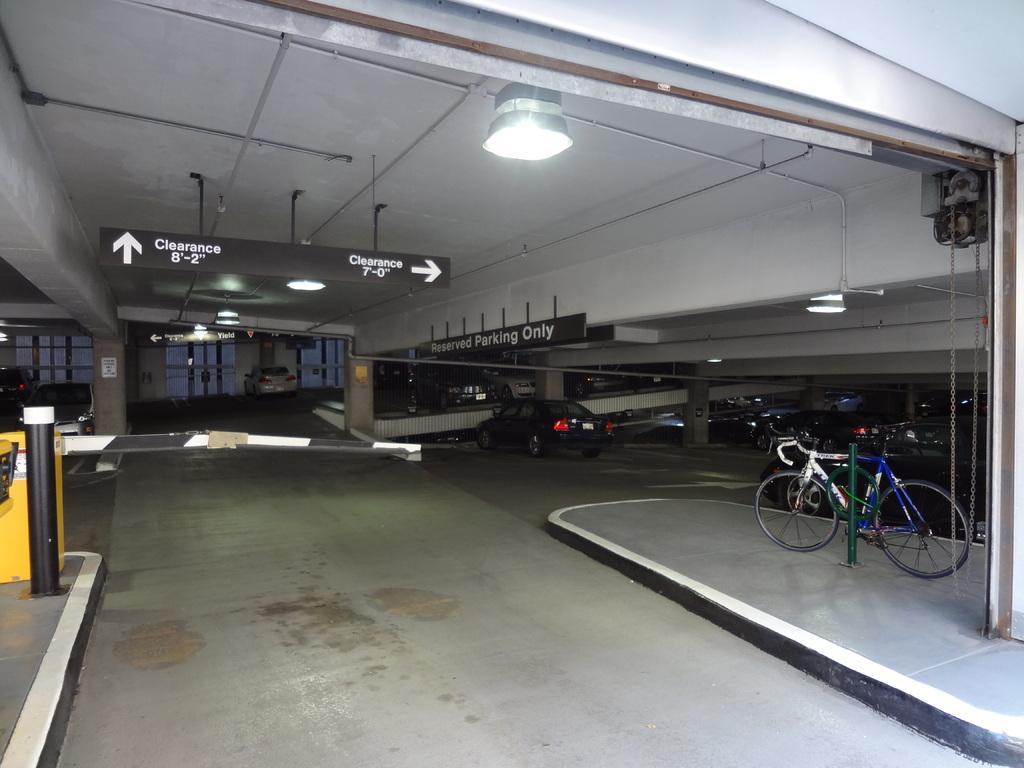Where was the image taken? The image was taken in a cellar. What can be seen on the right side of the image? There is a bicycle on the right side of the image. What type of vehicles are present in the image? There are cars in the image. Can you describe the position of the car in the center of the image? There is a car in the center of the image. What is visible at the top of the image? There are lights visible at the top of the image. What object can be seen in the image that might be used for displaying information or messages? There is a board in the image. What type of milk can be seen being poured from a star-shaped container in the image? There is no milk or star-shaped container present in the image. 